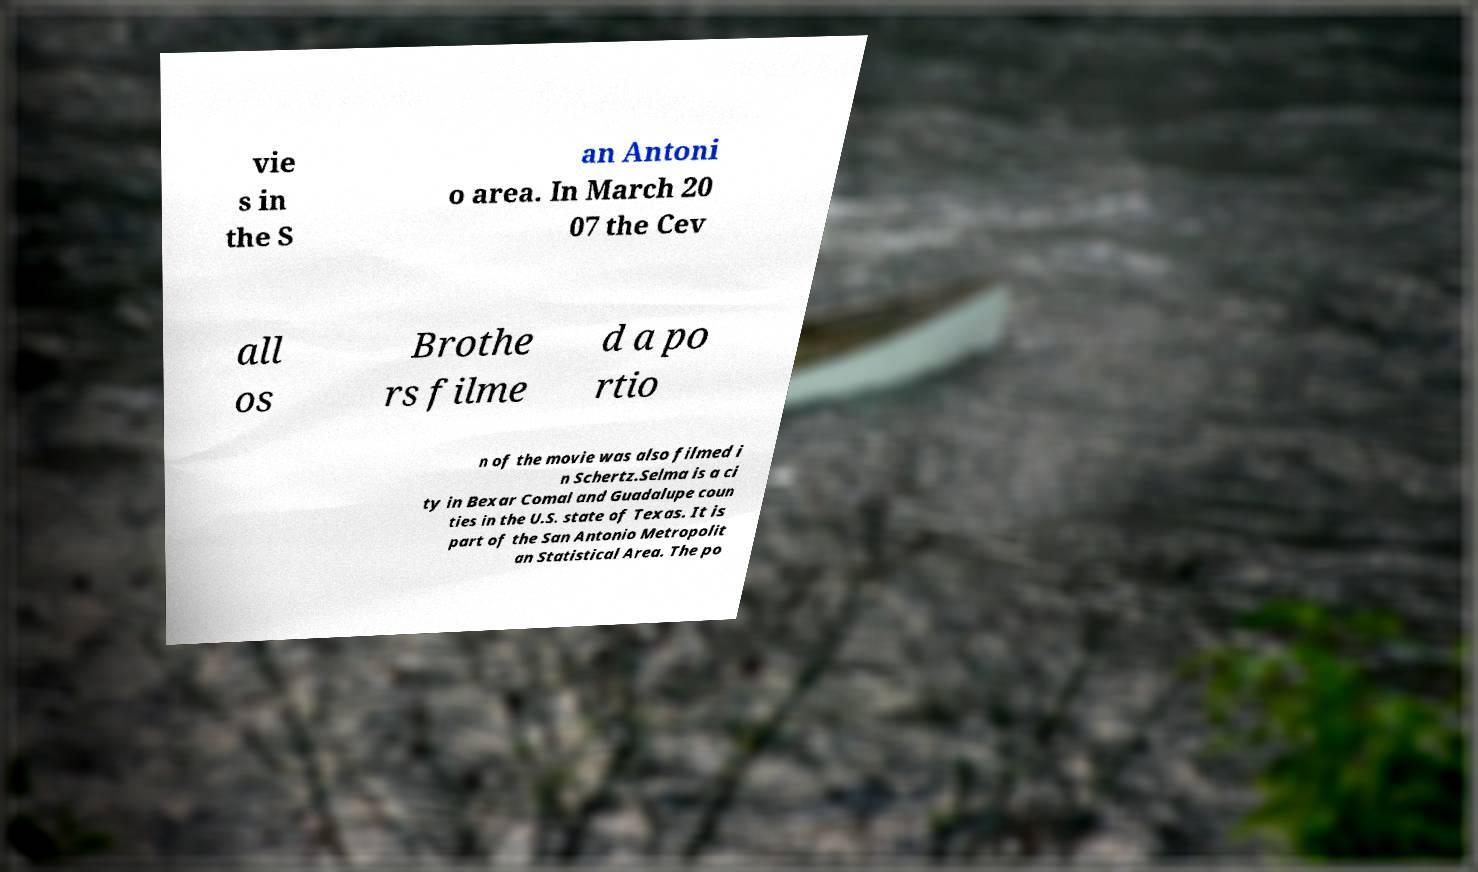Could you extract and type out the text from this image? vie s in the S an Antoni o area. In March 20 07 the Cev all os Brothe rs filme d a po rtio n of the movie was also filmed i n Schertz.Selma is a ci ty in Bexar Comal and Guadalupe coun ties in the U.S. state of Texas. It is part of the San Antonio Metropolit an Statistical Area. The po 